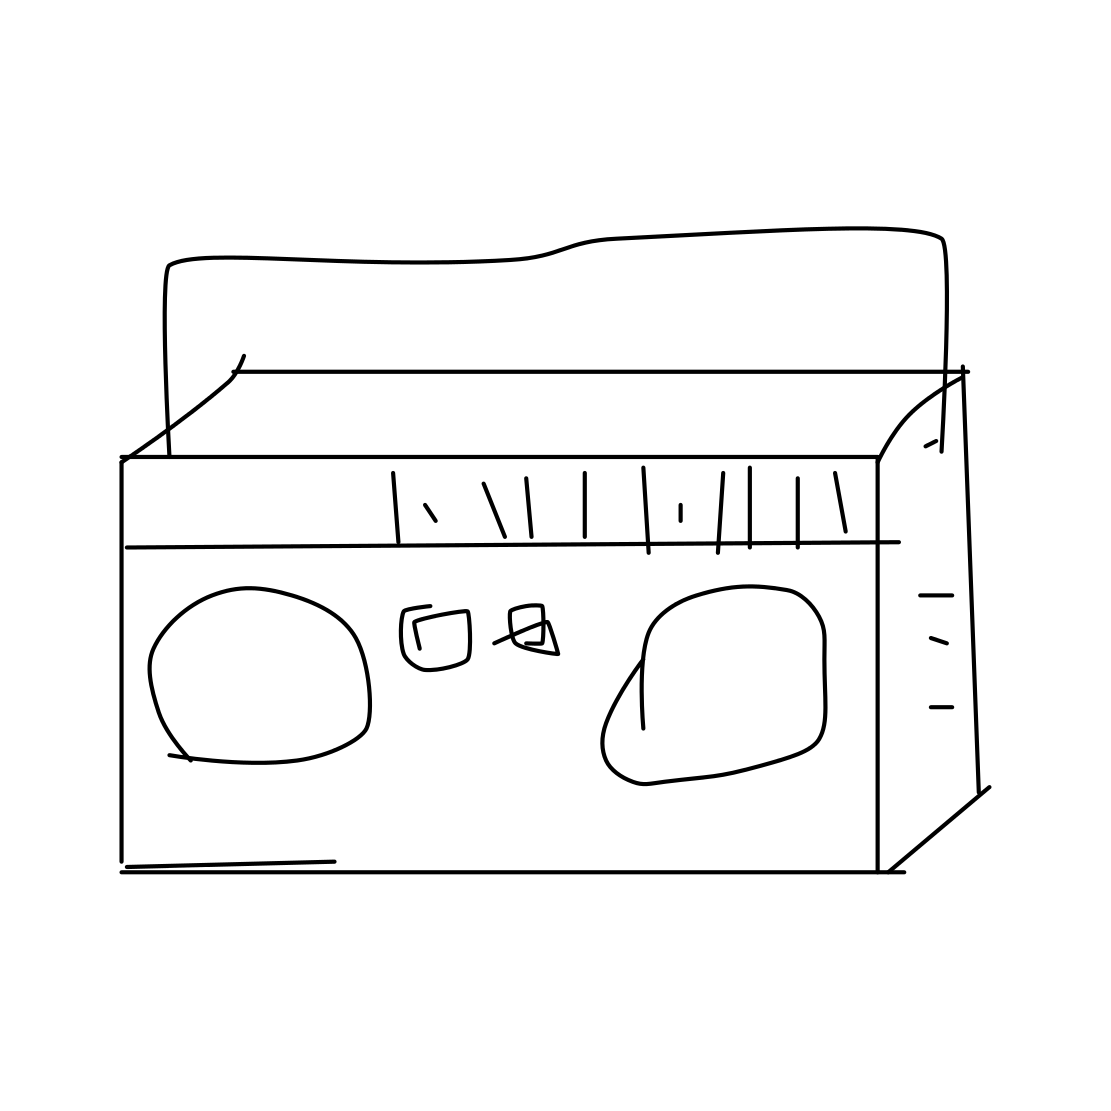Is this object still in use today? While not as widespread as during its peak popularity, cassette tapes are still used by some enthusiasts and musicians. They're appreciated for their nostalgic value and the distinct audio quality they provide, known as the 'analog warmth.' Additionally, they sometimes make a resurgence in pop culture and niche markets as a retro medium for music distribution. 